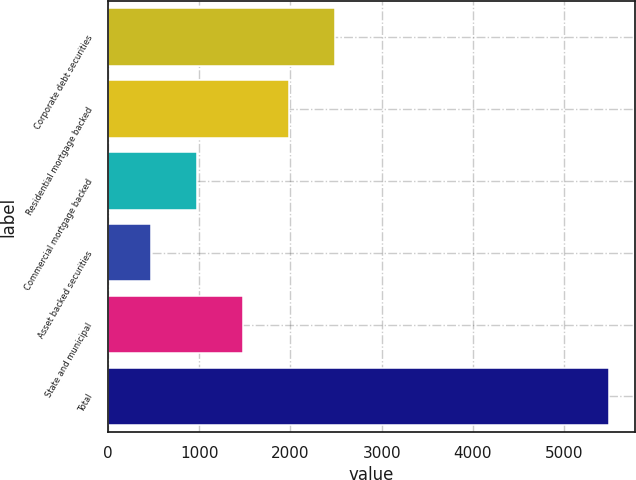Convert chart. <chart><loc_0><loc_0><loc_500><loc_500><bar_chart><fcel>Corporate debt securities<fcel>Residential mortgage backed<fcel>Commercial mortgage backed<fcel>Asset backed securities<fcel>State and municipal<fcel>Total<nl><fcel>2484.6<fcel>1982.7<fcel>978.9<fcel>477<fcel>1480.8<fcel>5496<nl></chart> 